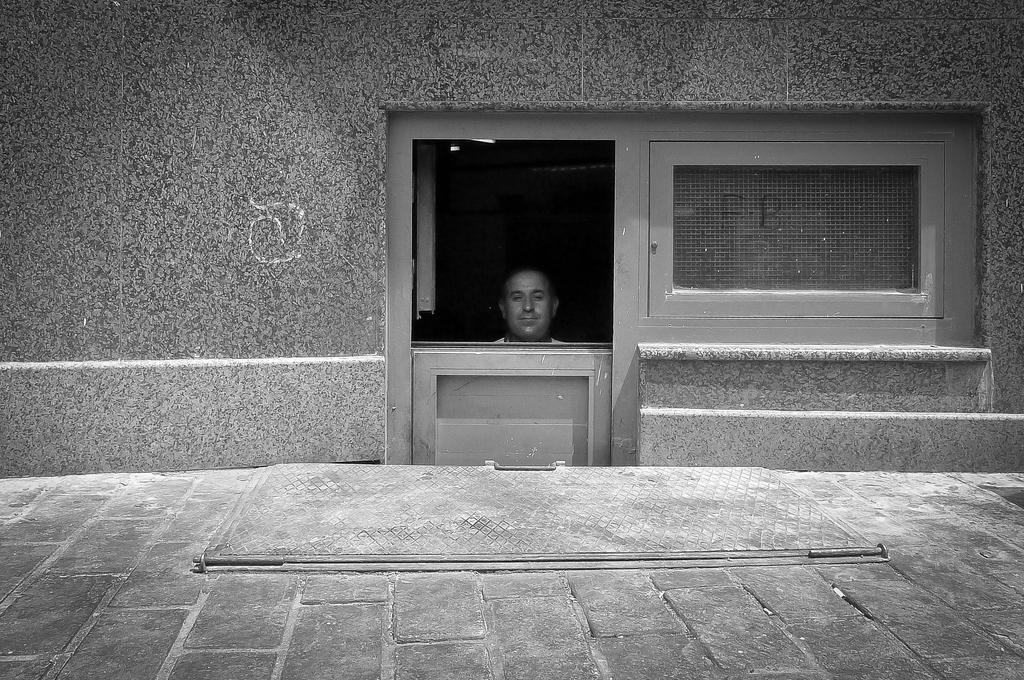Describe this image in one or two sentences. In this image we can see a house. There are few windows in the image. There is a person in the image. 